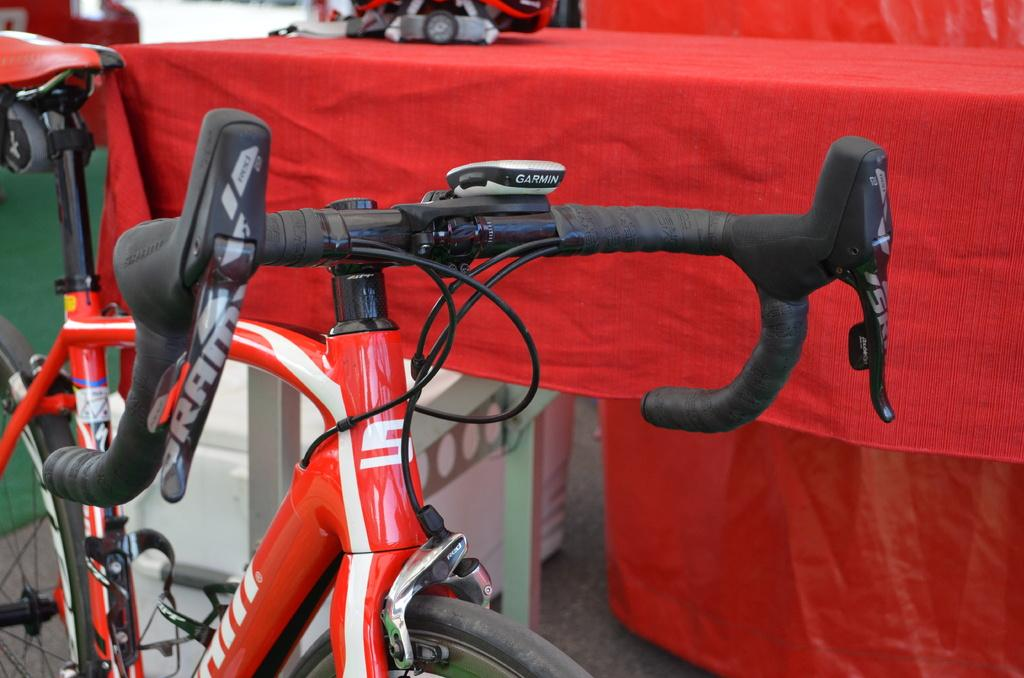What color is the bicycle in the image? The bicycle in the image is red-colored. Where is the bicycle located in the image? The bicycle is on the ground. What other object can be seen in the image besides the bicycle? There is a table in the image. What is the table covered with? The table is covered with a red-colored cloth. Can you see a giraffe standing next to the bicycle in the image? No, there is no giraffe present in the image. What reward is being offered for riding the bicycle in the image? There is no mention of a reward or any indication that the bicycle is being used in the image. 